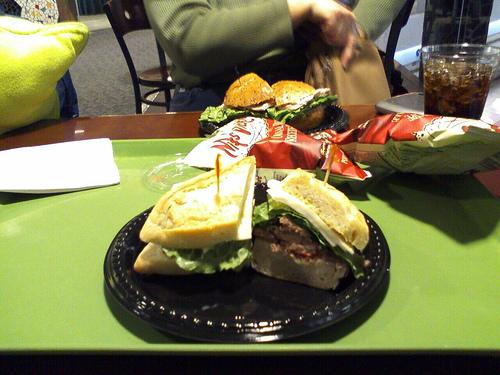Is that a glass of lemonade?
Concise answer only. No. Is this fast food?
Be succinct. Yes. Is there food other than the sandwiches?
Answer briefly. Yes. 